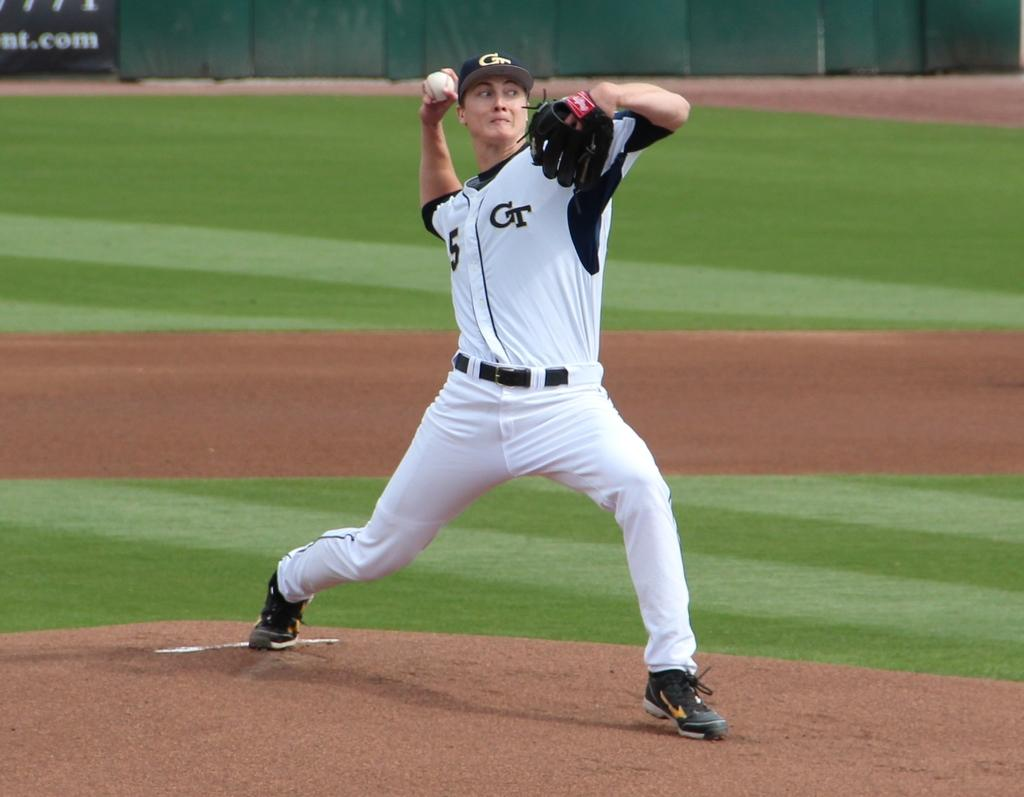<image>
Give a short and clear explanation of the subsequent image. A baseball player for GT is throwing a baseball on a field. 